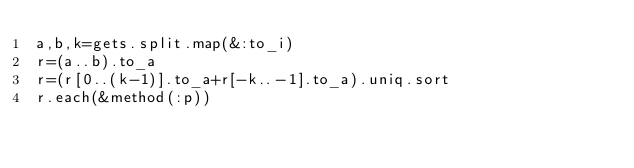<code> <loc_0><loc_0><loc_500><loc_500><_Ruby_>a,b,k=gets.split.map(&:to_i)
r=(a..b).to_a
r=(r[0..(k-1)].to_a+r[-k..-1].to_a).uniq.sort
r.each(&method(:p))
</code> 